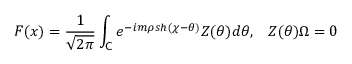Convert formula to latex. <formula><loc_0><loc_0><loc_500><loc_500>F ( x ) = \frac { 1 } { \sqrt { 2 \pi } } \int _ { C } e ^ { - i m \rho s h ( \chi - \theta ) } Z ( \theta ) d \theta , \, Z ( \theta ) \Omega = 0 \,</formula> 